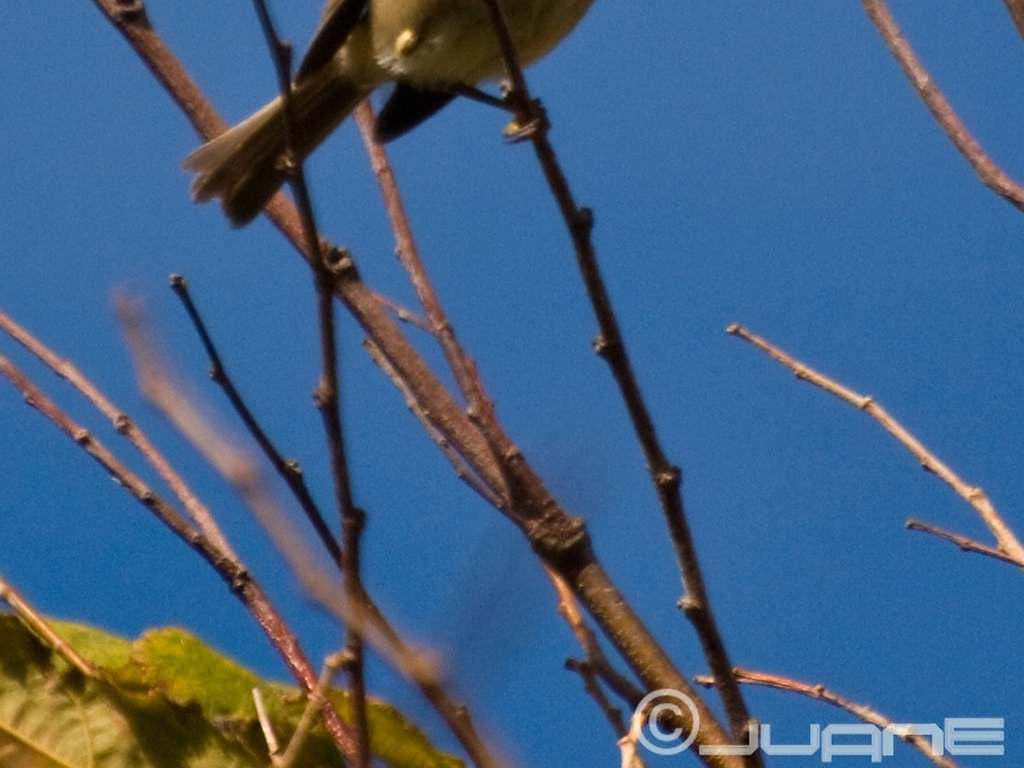What issues are present in the image besides noise? Aside from noise, the primary issue with the image is its distinct blurriness. This affects the sharpness and clarity of the subject, which appears to be a bird perched among branches. The lack of sharp focus makes it difficult to discern fine details, such as the texture of the bird's feathers or the subtle distinctions between twigs. This could be due to camera shake, incorrect focus settings, or movement from the bird itself when the photo was taken. 